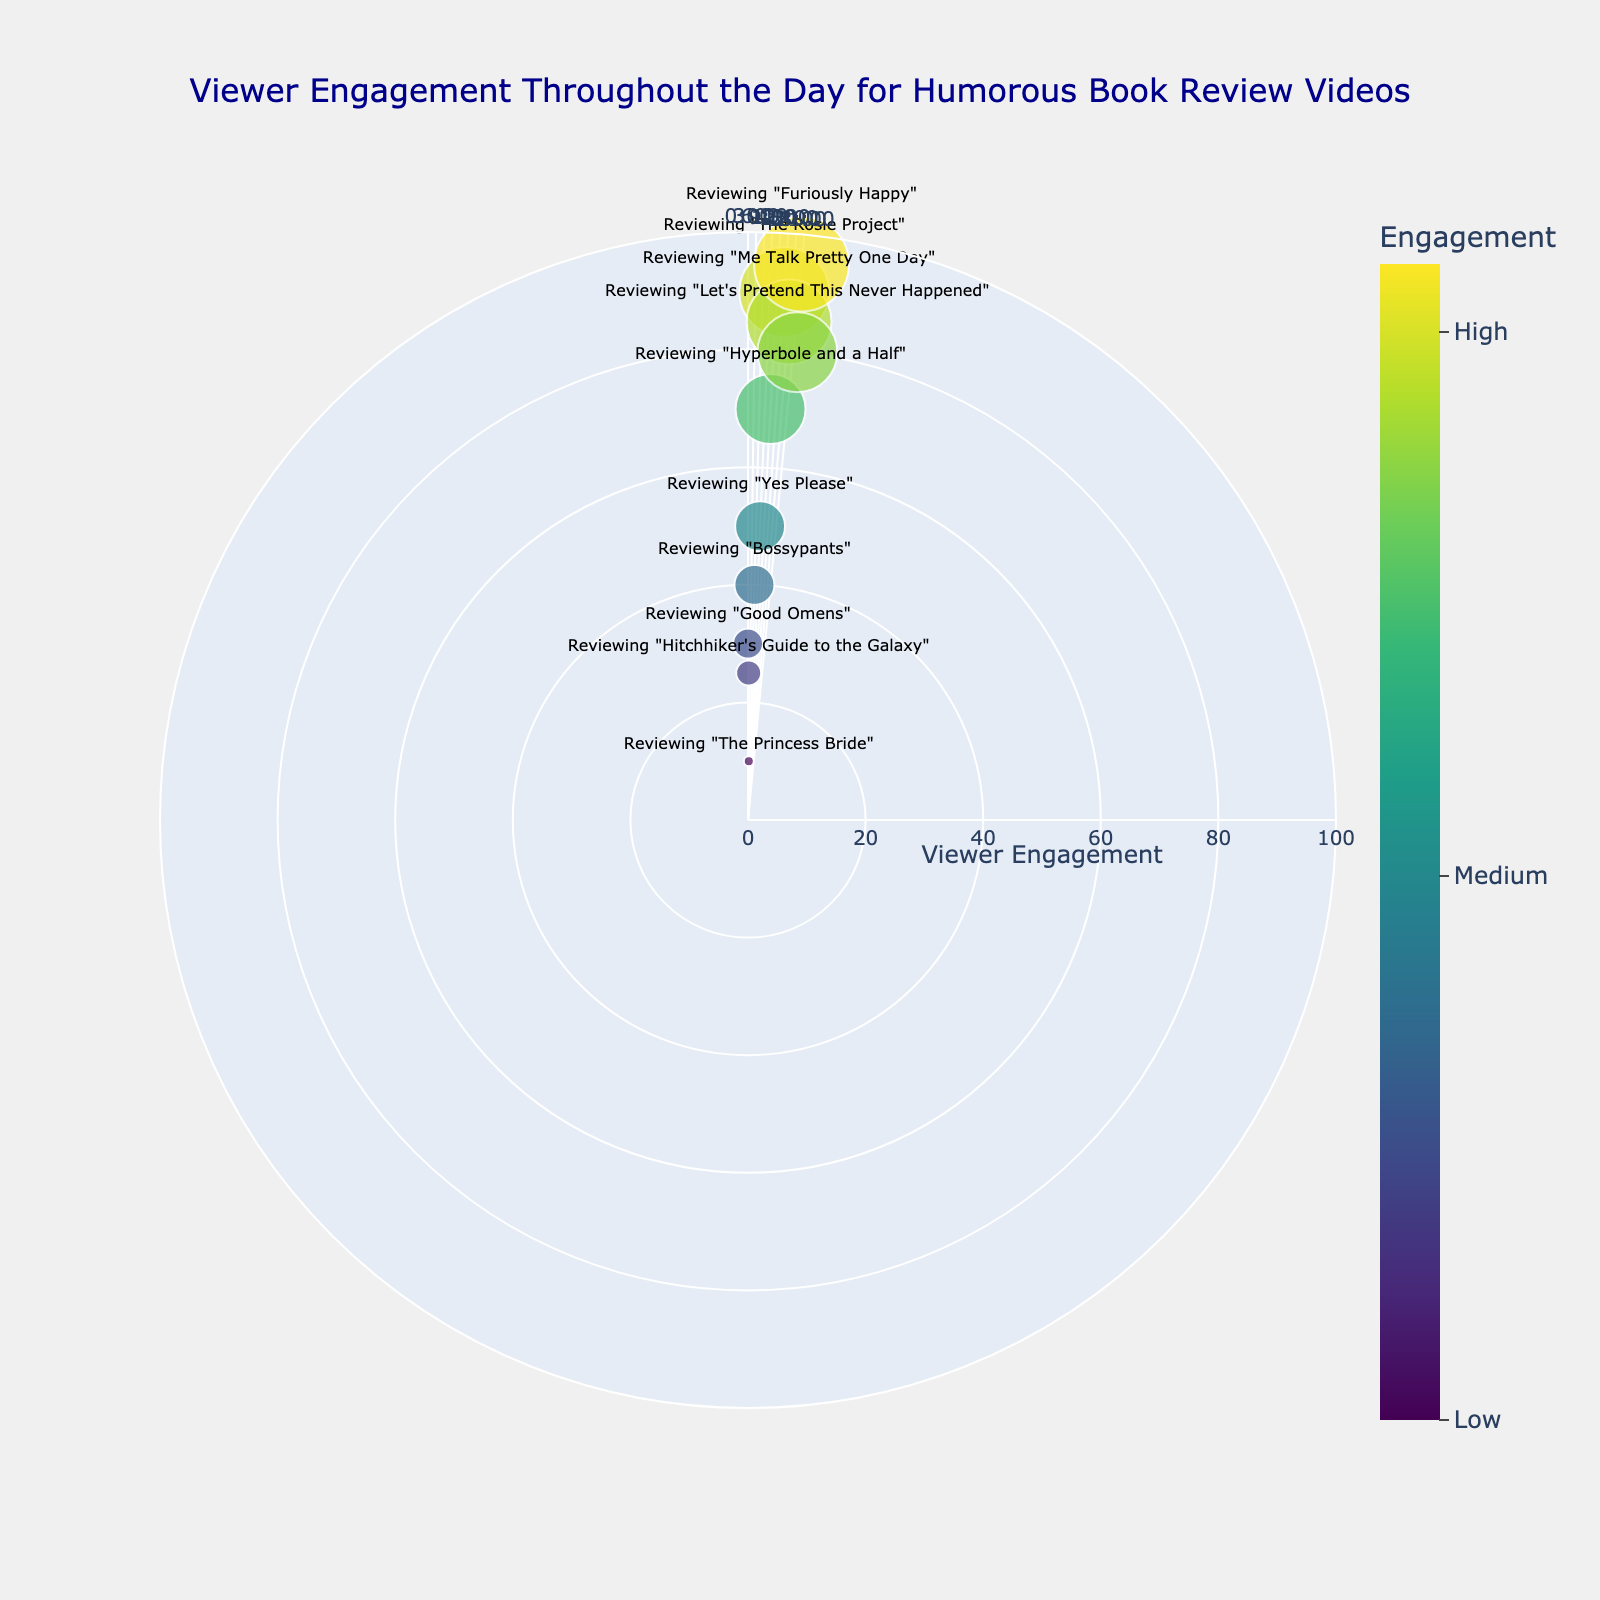What is the title of the plot? The title is usually found at the top of the figure. In this plot, it is centrally located and reads "Viewer Engagement Throughout the Day for Humorous Book Review Videos".
Answer: Viewer Engagement Throughout the Day for Humorous Book Review Videos Which book review video has the highest viewer engagement? Look for the data point with the highest radial distance. The label near this point should mention the book title. The highest engagement is 95, which is for the video reviewing "Furiously Happy".
Answer: Reviewing "Furiously Happy" What time of day has the lowest viewer engagement? Identify the data point closest to the center (r=10). The custom hover data or label should indicate the time, which is 03:00 for "The Princess Bride".
Answer: 03:00 How many review videos have viewer engagement equal to or greater than 80? Count the number of data points where the radial distance (viewer engagement) is greater than or equal to 80. In this figure, there are three such points: "Let's Pretend This Never Happened", "Me Talk Pretty One Day", and "Furiously Happy".
Answer: 3 What is the average viewer engagement for the book review videos at 9:00 and 15:00? Identify the viewer engagement values at these times. For 9:00, it's 50 ("Yes Please"), and for 15:00, it's 90 ("The Rosie Project"). The average is calculated as (50 + 90) / 2.
Answer: 70 Which book review video attracts more engagement, "Good Omens" or "Bossypants"? Compare the radial distances for these videos. "Good Omens" at 00:00 has an engagement of 30, while "Bossypants" at 06:00 has an engagement of 40.
Answer: "Bossypants" What’s the range of viewer engagement values in the plot? The range is determined by subtracting the smallest engagement value from the largest. The smallest engagement is 10 ("The Princess Bride"), and the largest is 95 ("Furiously Happy"). The range is 95 - 10.
Answer: 85 Which review video represents the peak of viewer engagement during the morning hours (06:00 to 12:00)? Look at the engagement values between 06:00 and 12:00. "Hyperbole and a Half" at 12:00 has the highest engagement of 70 within this time frame.
Answer: "Hyperbole and a Half" What color corresponds to the highest viewer engagement on the color scale? The highest viewer engagement is 95. The color scale is Viridis, and the color bar shows that the highest engagement corresponds to the darkest color.
Answer: Darkest color on the color scale 